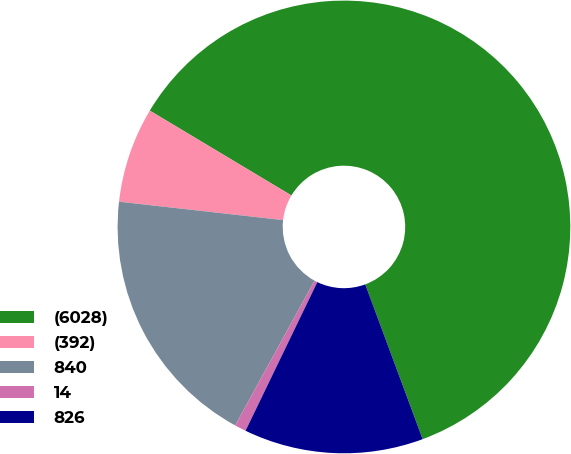Convert chart. <chart><loc_0><loc_0><loc_500><loc_500><pie_chart><fcel>(6028)<fcel>(392)<fcel>840<fcel>14<fcel>826<nl><fcel>60.76%<fcel>6.81%<fcel>18.8%<fcel>0.82%<fcel>12.81%<nl></chart> 